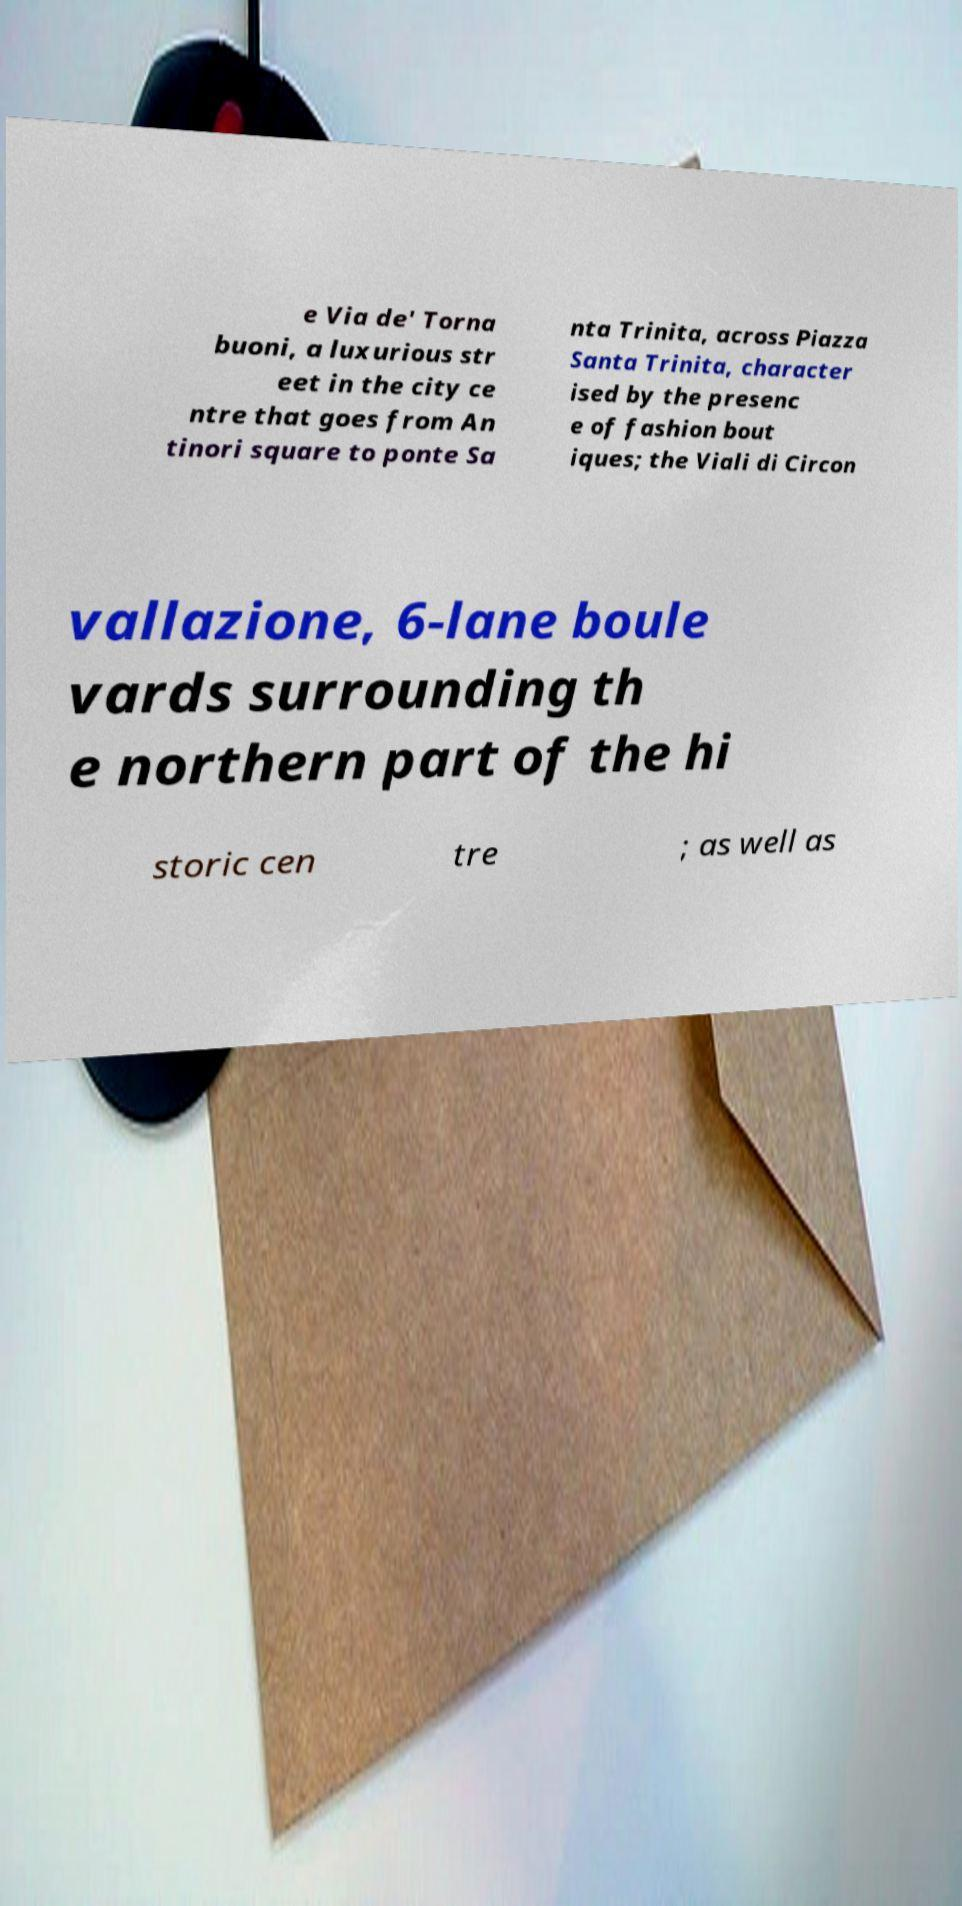Please identify and transcribe the text found in this image. e Via de' Torna buoni, a luxurious str eet in the city ce ntre that goes from An tinori square to ponte Sa nta Trinita, across Piazza Santa Trinita, character ised by the presenc e of fashion bout iques; the Viali di Circon vallazione, 6-lane boule vards surrounding th e northern part of the hi storic cen tre ; as well as 